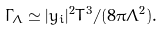<formula> <loc_0><loc_0><loc_500><loc_500>\Gamma _ { \Lambda } \simeq | y _ { i } | ^ { 2 } T ^ { 3 } / ( 8 \pi \Lambda ^ { 2 } ) .</formula> 